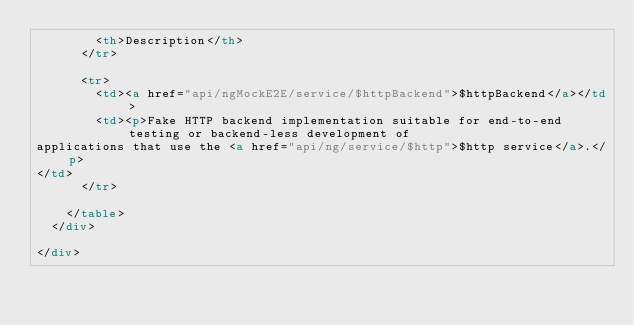Convert code to text. <code><loc_0><loc_0><loc_500><loc_500><_HTML_>        <th>Description</th>
      </tr>
      
      <tr>
        <td><a href="api/ngMockE2E/service/$httpBackend">$httpBackend</a></td>
        <td><p>Fake HTTP backend implementation suitable for end-to-end testing or backend-less development of
applications that use the <a href="api/ng/service/$http">$http service</a>.</p>
</td>
      </tr>
      
    </table>
  </div>
  
</div>





</code> 